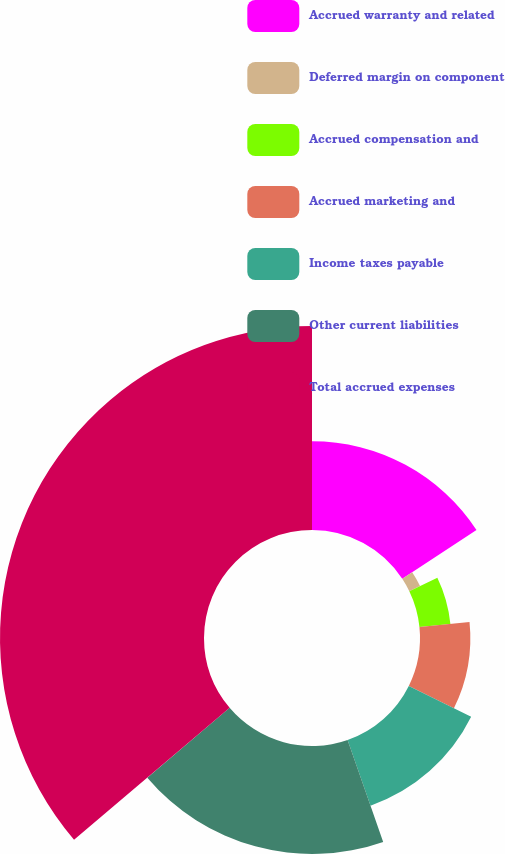Convert chart to OTSL. <chart><loc_0><loc_0><loc_500><loc_500><pie_chart><fcel>Accrued warranty and related<fcel>Deferred margin on component<fcel>Accrued compensation and<fcel>Accrued marketing and<fcel>Income taxes payable<fcel>Other current liabilities<fcel>Total accrued expenses<nl><fcel>15.75%<fcel>2.11%<fcel>5.52%<fcel>8.93%<fcel>12.34%<fcel>19.15%<fcel>36.19%<nl></chart> 